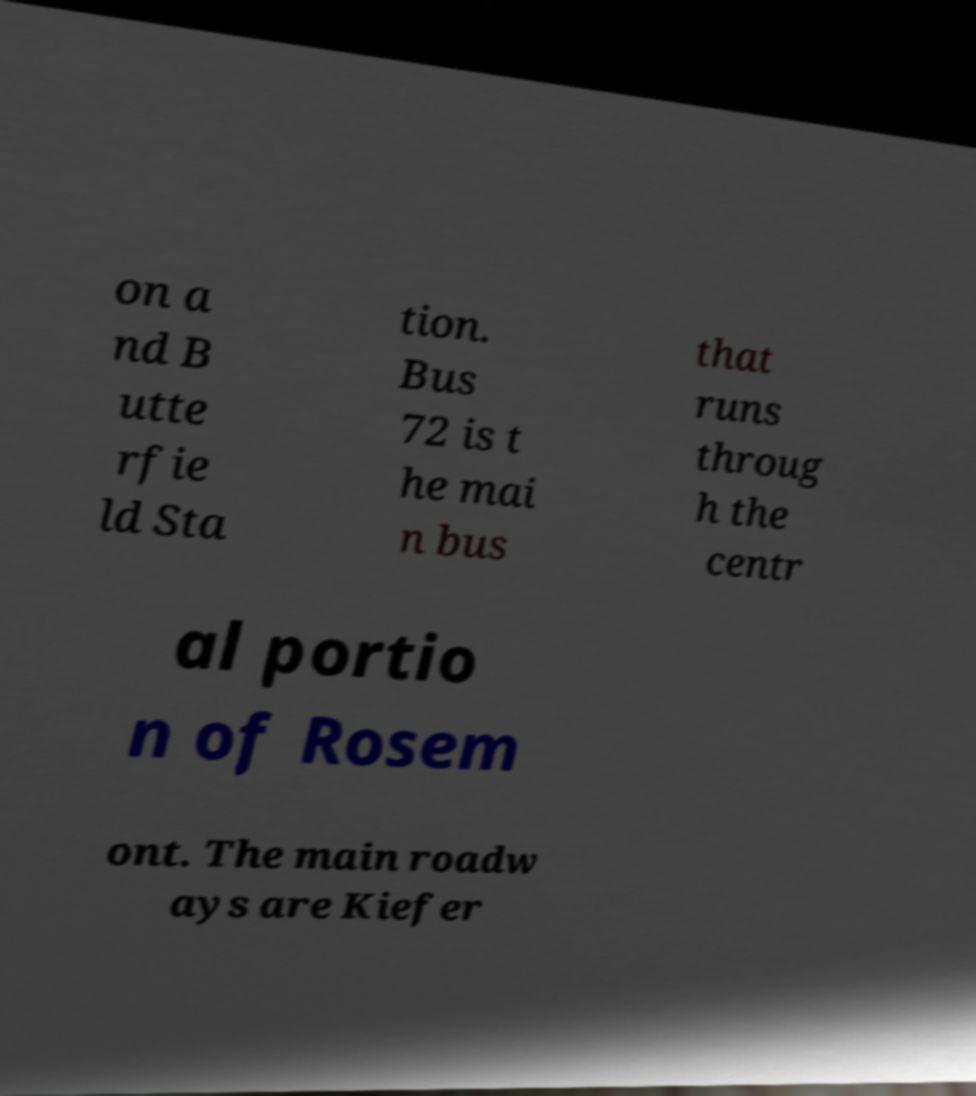Please identify and transcribe the text found in this image. on a nd B utte rfie ld Sta tion. Bus 72 is t he mai n bus that runs throug h the centr al portio n of Rosem ont. The main roadw ays are Kiefer 